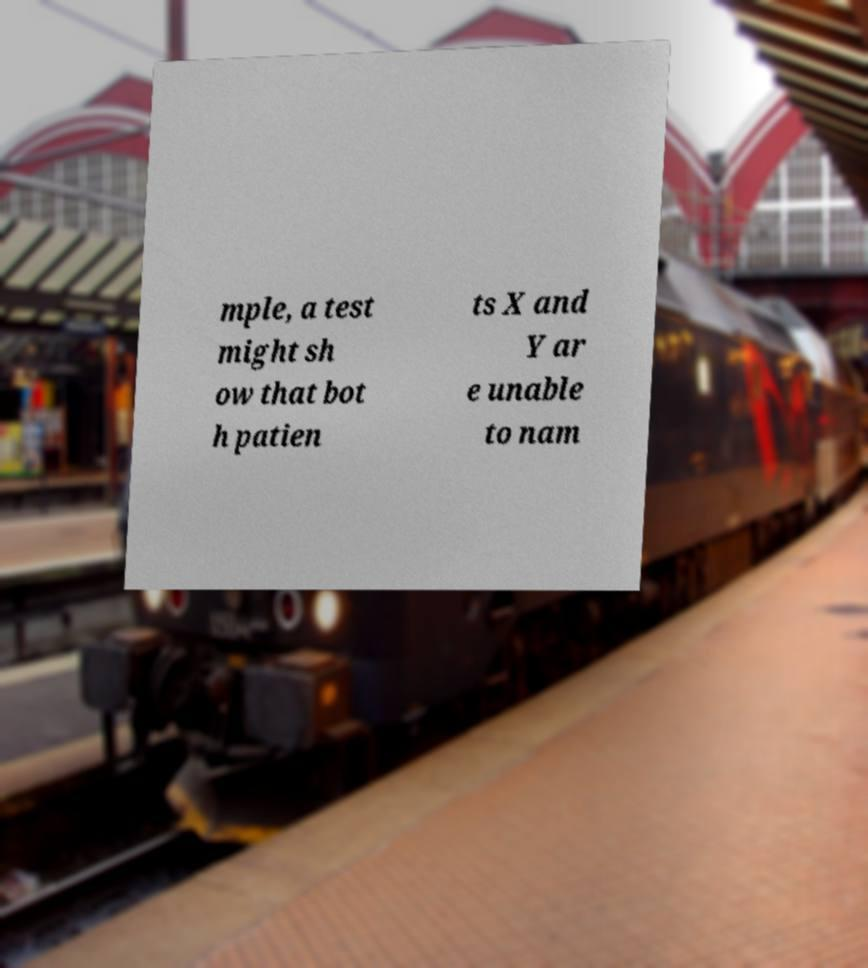Can you read and provide the text displayed in the image?This photo seems to have some interesting text. Can you extract and type it out for me? mple, a test might sh ow that bot h patien ts X and Y ar e unable to nam 